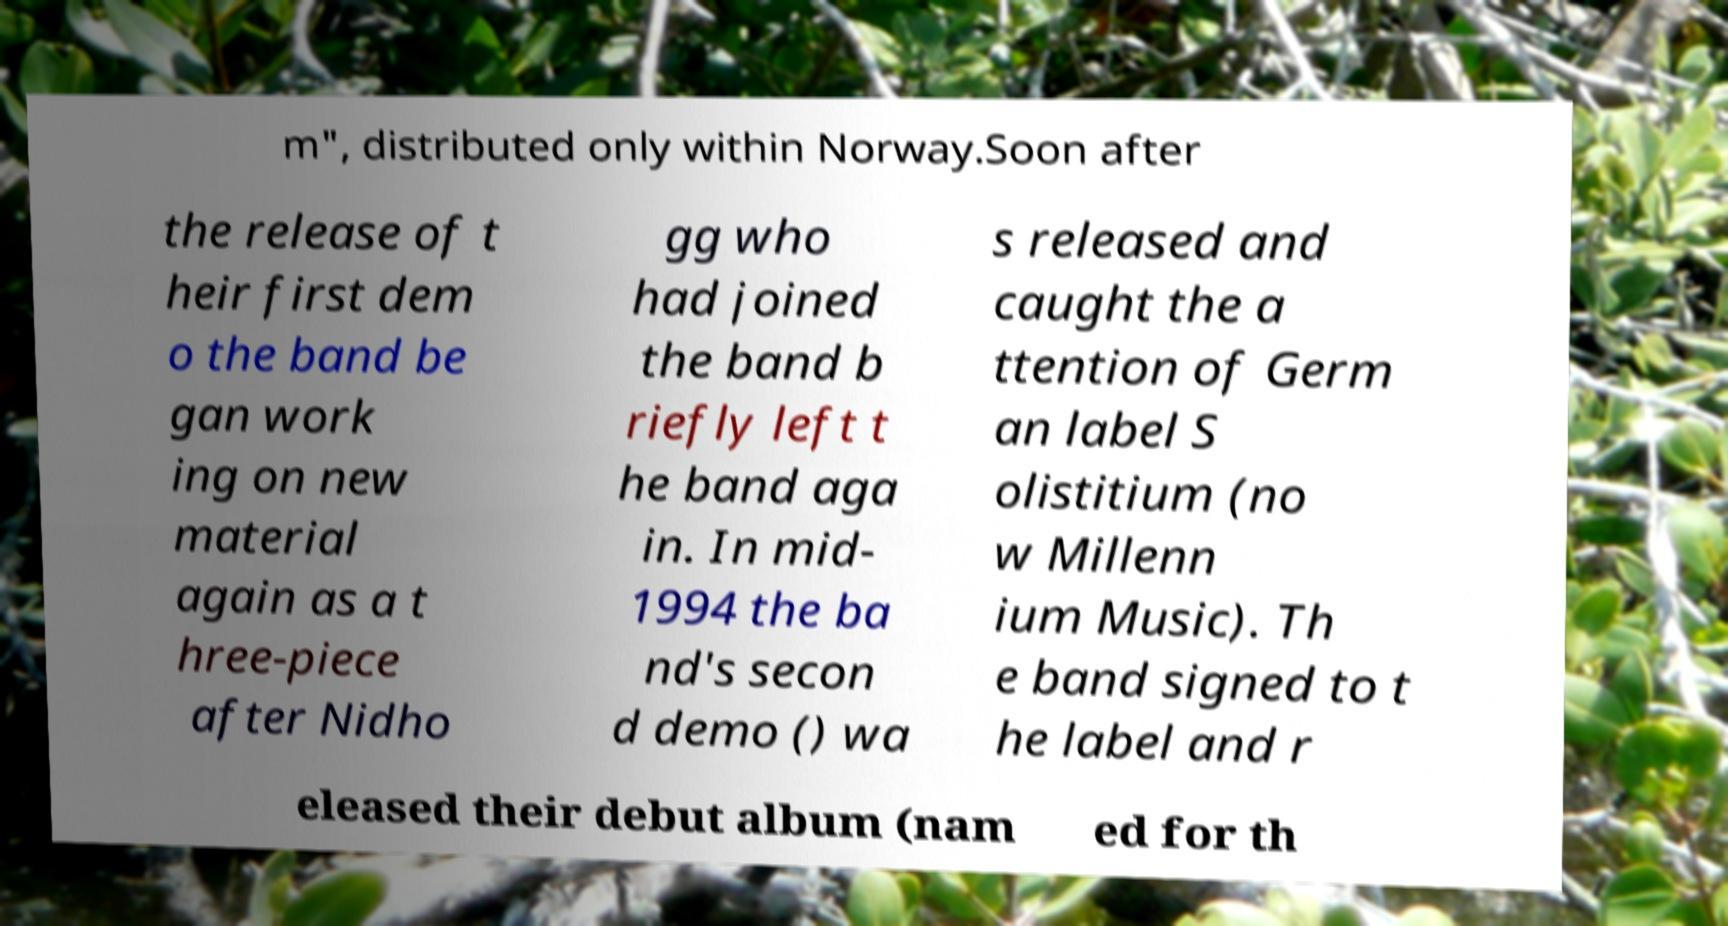Could you extract and type out the text from this image? m", distributed only within Norway.Soon after the release of t heir first dem o the band be gan work ing on new material again as a t hree-piece after Nidho gg who had joined the band b riefly left t he band aga in. In mid- 1994 the ba nd's secon d demo () wa s released and caught the a ttention of Germ an label S olistitium (no w Millenn ium Music). Th e band signed to t he label and r eleased their debut album (nam ed for th 